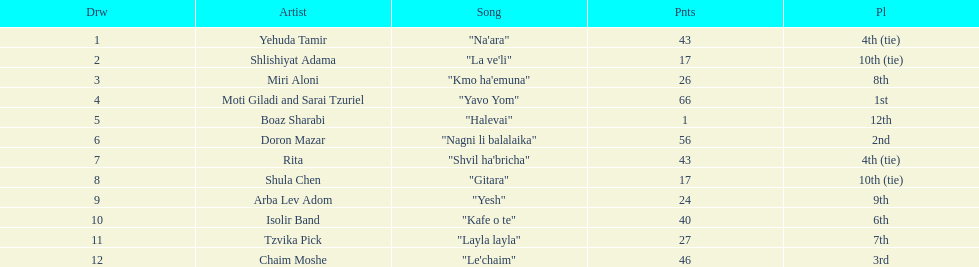What are the number of times an artist earned first place? 1. 